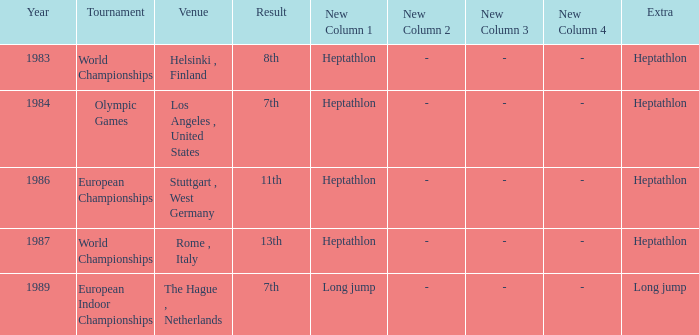How often are the Olympic games hosted? 1984.0. 